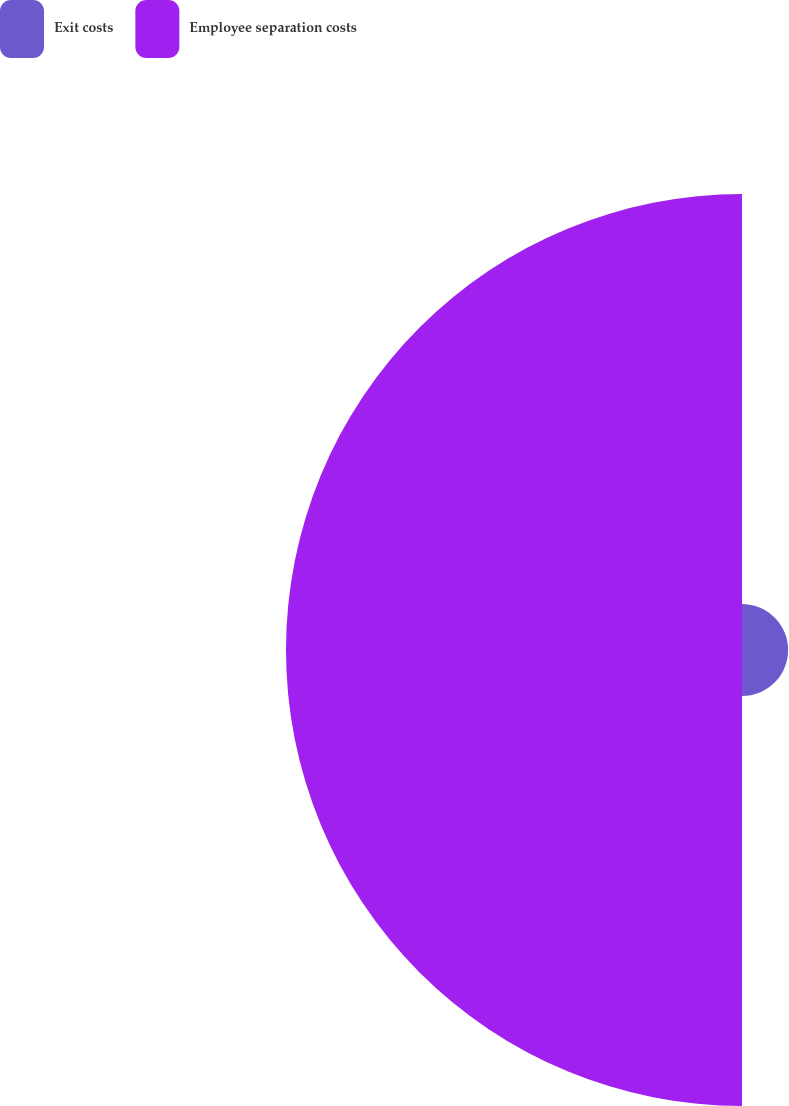Convert chart to OTSL. <chart><loc_0><loc_0><loc_500><loc_500><pie_chart><fcel>Exit costs<fcel>Employee separation costs<nl><fcel>9.18%<fcel>90.82%<nl></chart> 